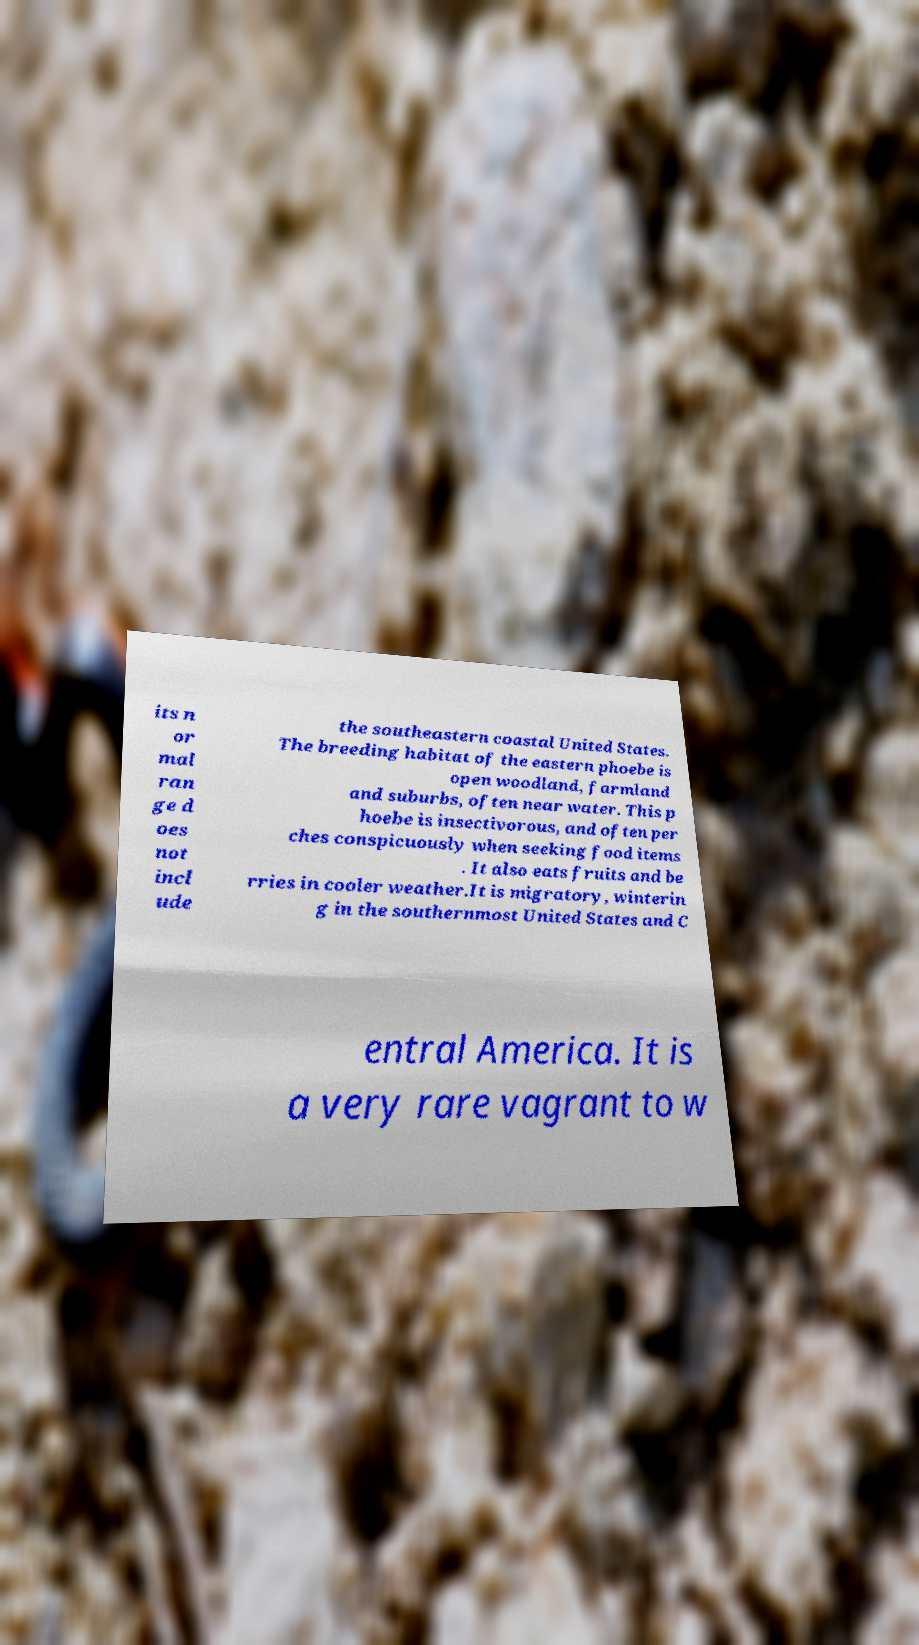Could you assist in decoding the text presented in this image and type it out clearly? its n or mal ran ge d oes not incl ude the southeastern coastal United States. The breeding habitat of the eastern phoebe is open woodland, farmland and suburbs, often near water. This p hoebe is insectivorous, and often per ches conspicuously when seeking food items . It also eats fruits and be rries in cooler weather.It is migratory, winterin g in the southernmost United States and C entral America. It is a very rare vagrant to w 